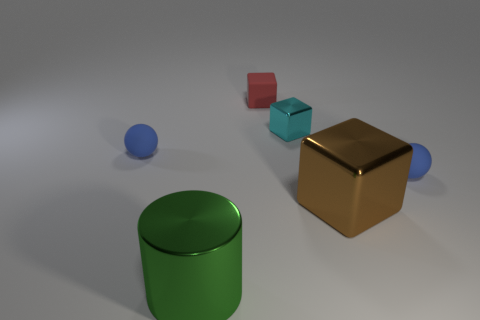Subtract all gray balls. Subtract all yellow cylinders. How many balls are left? 2 Add 4 tiny red blocks. How many objects exist? 10 Subtract all spheres. How many objects are left? 4 Add 1 small yellow shiny balls. How many small yellow shiny balls exist? 1 Subtract 0 purple blocks. How many objects are left? 6 Subtract all big yellow spheres. Subtract all tiny blue things. How many objects are left? 4 Add 5 small blue balls. How many small blue balls are left? 7 